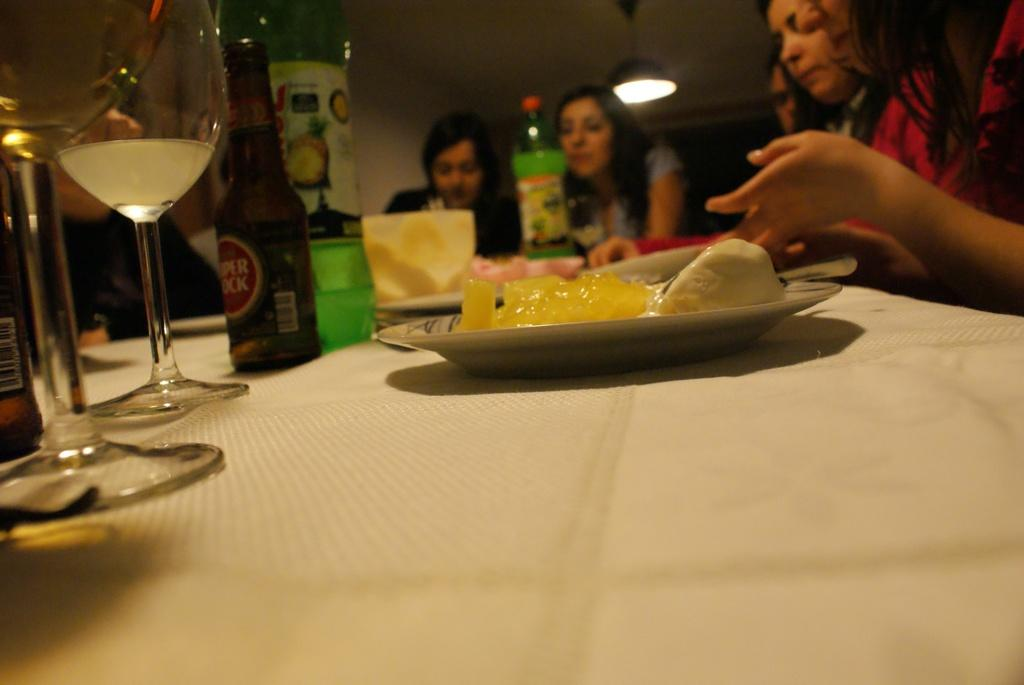What objects are on the table in the image? There are glasses with liquid, bottles, and a plate on the table. What is on the plate? There is food on the plate. What are the people in the image doing? There are persons sitting on chairs. What is the source of light in the image? There is a light on top. What type of group activity is taking place in the image? There is no group activity present in the image; it shows people sitting on chairs with objects on the table. Can you tell me how the spade is being used in the image? There is no spade present in the image. 